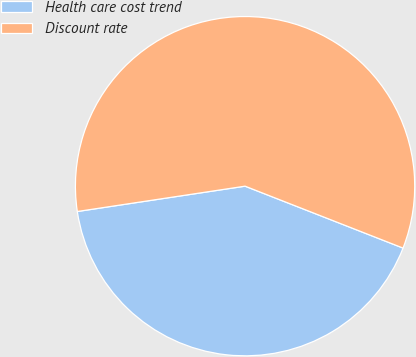Convert chart to OTSL. <chart><loc_0><loc_0><loc_500><loc_500><pie_chart><fcel>Health care cost trend<fcel>Discount rate<nl><fcel>41.67%<fcel>58.33%<nl></chart> 